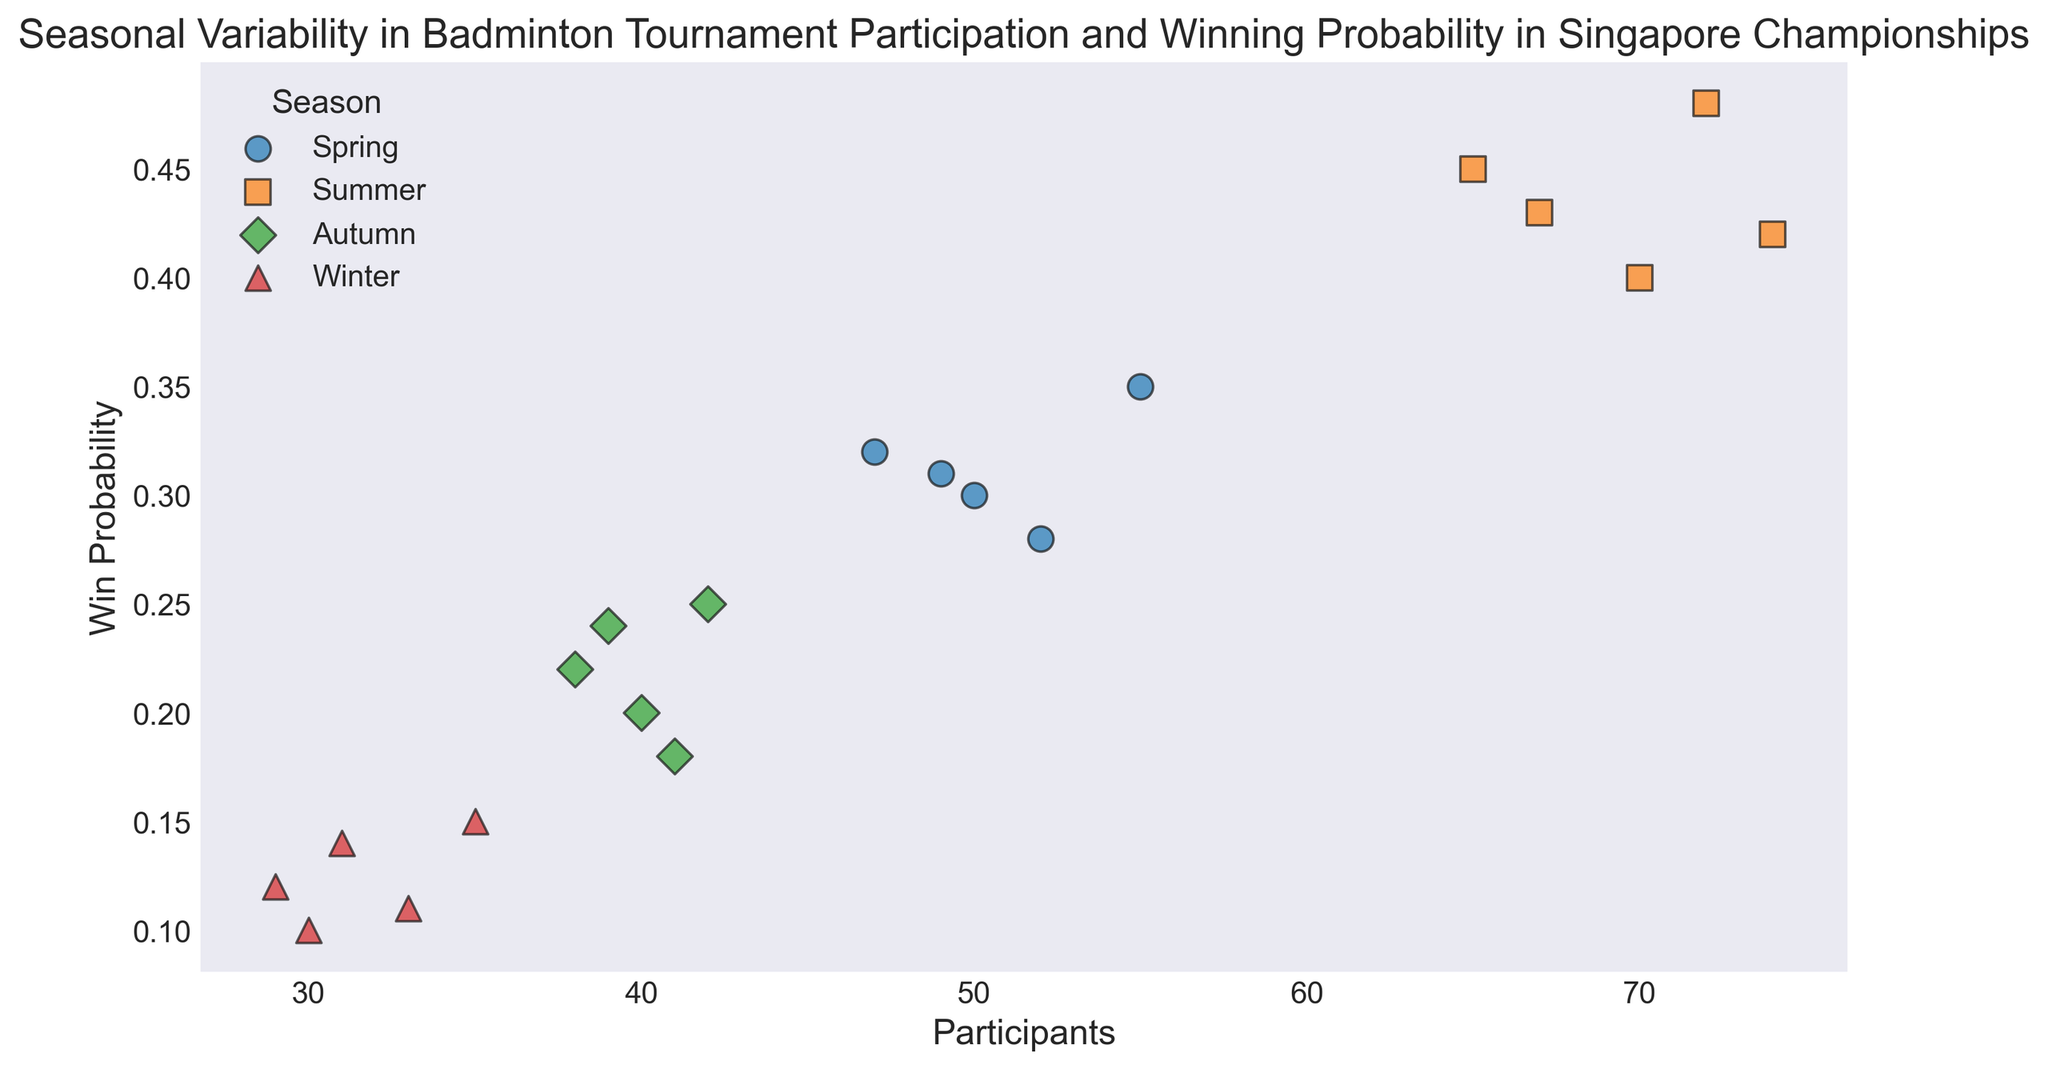What season shows the highest number of participants in any single tournament? By observing the scatter plot, we can see that the number of participants reaches its highest point under the "Summer" label. This can be identified as the markers for the Summer season (squares) have one point at around 74 participants.
Answer: Summer Which season has the lowest winning probability in general? Looking at the scatter plot, the lowest cluster of points with the least win probability is under the "Winter" label, where win probabilities are clustered around 0.10 to 0.15.
Answer: Winter In which season does the winning probability seem to be the most spread out? By examining the spread of the dots for each season, Summer shows the widest range of win probabilities, from around 0.40 to around 0.48. This indicates more variability in win probabilities.
Answer: Summer Compare the average number of participants between Spring and Winter seasons. Which one is higher? From the scatter plot, count the points and observe the typical values for participants. Spring has more points spread around higher values in the range 47-55, while Winter's values range around 29-35. Summing and averaging these approximate values would show that Spring has a higher average.
Answer: Spring Are there any seasons where participants and win probabilities show a positive correlation? Positive correlation can be observed if higher participant numbers correspond to higher win probabilities. By looking at the scatter plot, we see Summer (squares) indicates such a trend, as more participants generally relate to higher win probabilities.
Answer: Summer What is the difference in the maximum win probability between Spring and Autumn? By finding the maximum win probabilities for Spring (which is about 0.35) and Autumn (which is about 0.25), the difference can be calculated as 0.35 - 0.25.
Answer: 0.10 Which season shows the lowest number of participants in any single tournament? Observing the scatter plot, Winter has a marker showing the smallest number of participants around 29.
Answer: Winter Compare the range of participants between Spring and Autumn. Range is the difference between the highest and lowest values for each season. Spring's participants range from 47 to 55 (8), while Autumn's range from 38 to 42 (4). Thus, Spring has a wider range.
Answer: Spring 